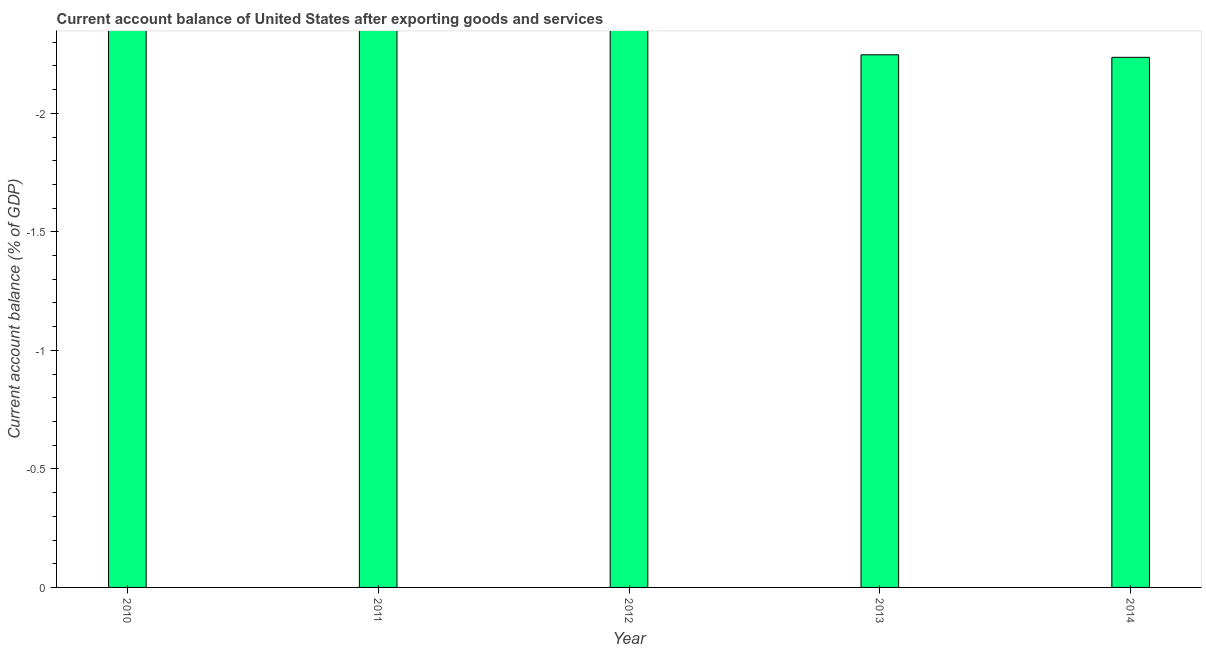Does the graph contain any zero values?
Keep it short and to the point. Yes. What is the title of the graph?
Your response must be concise. Current account balance of United States after exporting goods and services. What is the label or title of the X-axis?
Keep it short and to the point. Year. What is the label or title of the Y-axis?
Keep it short and to the point. Current account balance (% of GDP). Across all years, what is the minimum current account balance?
Provide a succinct answer. 0. What is the sum of the current account balance?
Keep it short and to the point. 0. What is the average current account balance per year?
Provide a short and direct response. 0. What is the median current account balance?
Offer a very short reply. 0. In how many years, is the current account balance greater than -1 %?
Provide a short and direct response. 0. How many years are there in the graph?
Your answer should be very brief. 5. What is the Current account balance (% of GDP) of 2013?
Provide a succinct answer. 0. 